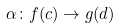<formula> <loc_0><loc_0><loc_500><loc_500>\alpha \colon f ( c ) \rightarrow g ( d )</formula> 